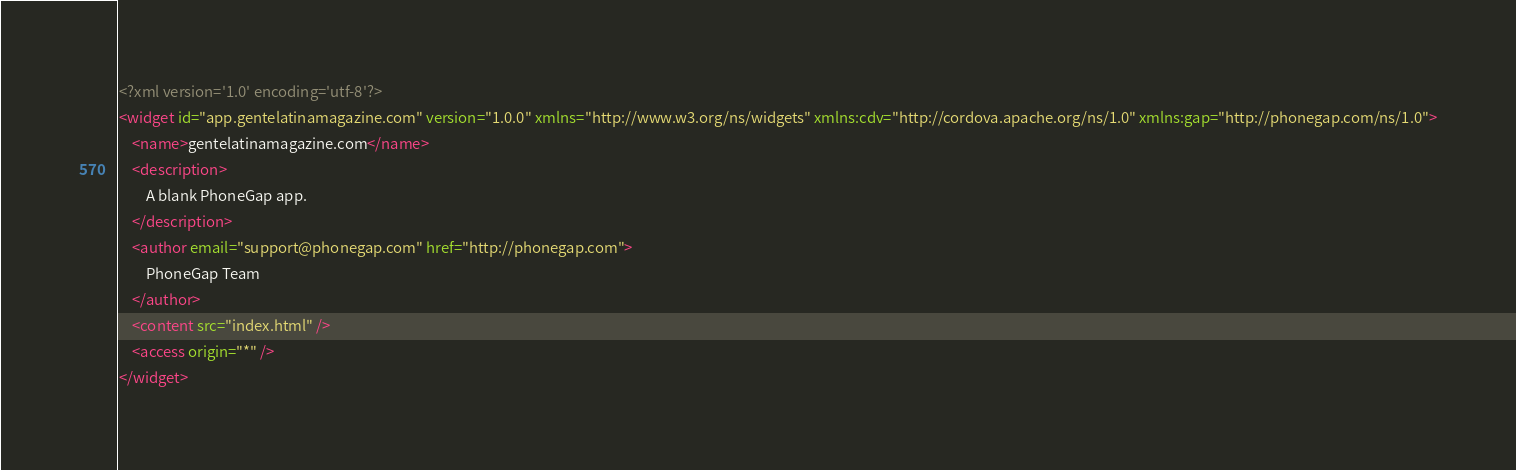<code> <loc_0><loc_0><loc_500><loc_500><_XML_><?xml version='1.0' encoding='utf-8'?>
<widget id="app.gentelatinamagazine.com" version="1.0.0" xmlns="http://www.w3.org/ns/widgets" xmlns:cdv="http://cordova.apache.org/ns/1.0" xmlns:gap="http://phonegap.com/ns/1.0">
    <name>gentelatinamagazine.com</name>
    <description>
        A blank PhoneGap app.
    </description>
    <author email="support@phonegap.com" href="http://phonegap.com">
        PhoneGap Team
    </author>
    <content src="index.html" />
    <access origin="*" />
</widget>
</code> 